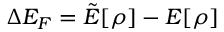<formula> <loc_0><loc_0><loc_500><loc_500>\Delta E _ { F } = \tilde { E } [ \rho ] - E [ \rho ]</formula> 